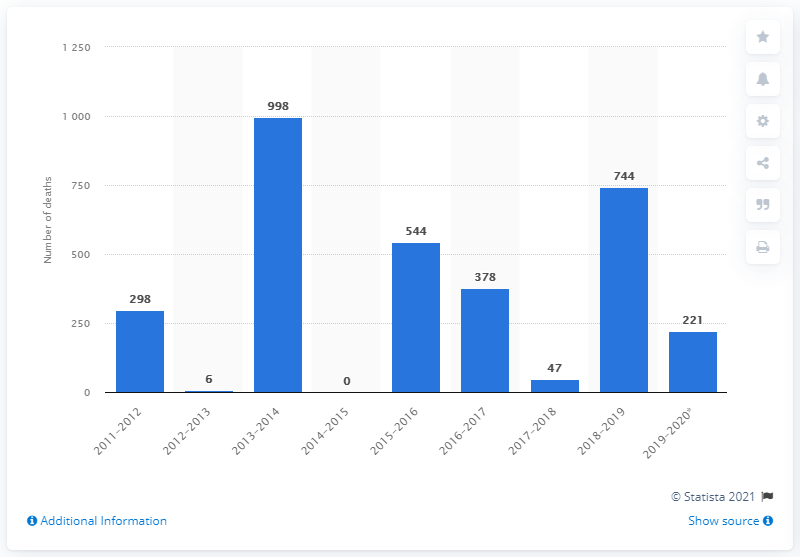Indicate a few pertinent items in this graphic. During the 2018-2019 flu season, a total of 744 deaths were attributed to swine flu. 